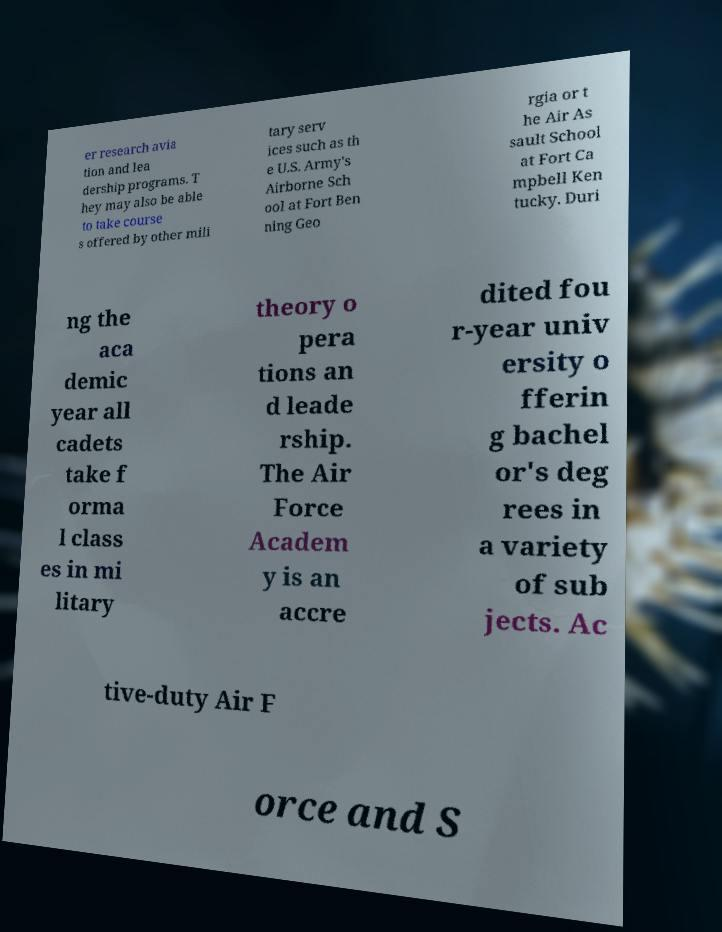What messages or text are displayed in this image? I need them in a readable, typed format. er research avia tion and lea dership programs. T hey may also be able to take course s offered by other mili tary serv ices such as th e U.S. Army's Airborne Sch ool at Fort Ben ning Geo rgia or t he Air As sault School at Fort Ca mpbell Ken tucky. Duri ng the aca demic year all cadets take f orma l class es in mi litary theory o pera tions an d leade rship. The Air Force Academ y is an accre dited fou r-year univ ersity o fferin g bachel or's deg rees in a variety of sub jects. Ac tive-duty Air F orce and S 